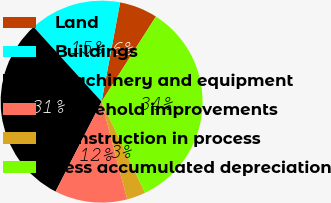<chart> <loc_0><loc_0><loc_500><loc_500><pie_chart><fcel>Land<fcel>Buildings<fcel>Machinery and equipment<fcel>Leasehold improvements<fcel>Construction in process<fcel>Less accumulated depreciation<nl><fcel>6.1%<fcel>14.69%<fcel>30.71%<fcel>11.6%<fcel>3.01%<fcel>33.88%<nl></chart> 